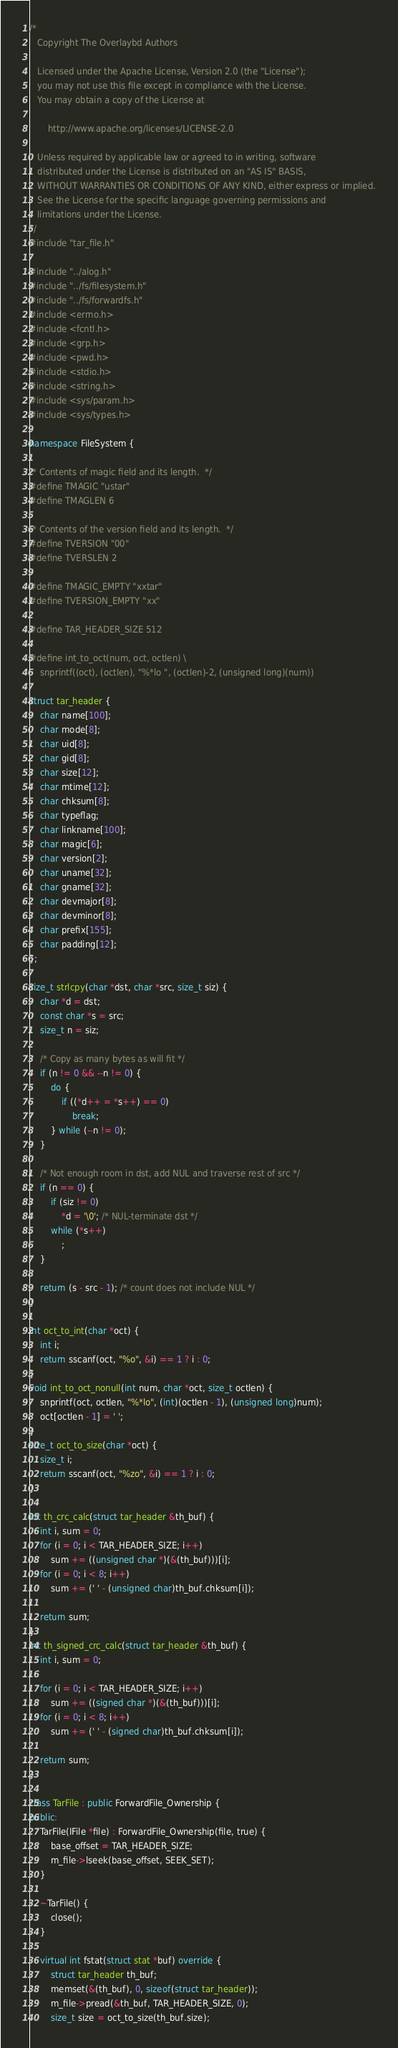<code> <loc_0><loc_0><loc_500><loc_500><_C++_>/*
   Copyright The Overlaybd Authors

   Licensed under the Apache License, Version 2.0 (the "License");
   you may not use this file except in compliance with the License.
   You may obtain a copy of the License at

       http://www.apache.org/licenses/LICENSE-2.0

   Unless required by applicable law or agreed to in writing, software
   distributed under the License is distributed on an "AS IS" BASIS,
   WITHOUT WARRANTIES OR CONDITIONS OF ANY KIND, either express or implied.
   See the License for the specific language governing permissions and
   limitations under the License.
*/
#include "tar_file.h"

#include "../alog.h"
#include "../fs/filesystem.h"
#include "../fs/forwardfs.h"
#include <errno.h>
#include <fcntl.h>
#include <grp.h>
#include <pwd.h>
#include <stdio.h>
#include <string.h>
#include <sys/param.h>
#include <sys/types.h>

namespace FileSystem {

/* Contents of magic field and its length.  */
#define TMAGIC "ustar"
#define TMAGLEN 6

/* Contents of the version field and its length.  */
#define TVERSION "00"
#define TVERSLEN 2

#define TMAGIC_EMPTY "xxtar"
#define TVERSION_EMPTY "xx"

#define TAR_HEADER_SIZE 512

#define int_to_oct(num, oct, octlen) \
    snprintf((oct), (octlen), "%*lo ", (octlen)-2, (unsigned long)(num))

struct tar_header {
    char name[100];
    char mode[8];
    char uid[8];
    char gid[8];
    char size[12];
    char mtime[12];
    char chksum[8];
    char typeflag;
    char linkname[100];
    char magic[6];
    char version[2];
    char uname[32];
    char gname[32];
    char devmajor[8];
    char devminor[8];
    char prefix[155];
    char padding[12];
};

size_t strlcpy(char *dst, char *src, size_t siz) {
    char *d = dst;
    const char *s = src;
    size_t n = siz;

    /* Copy as many bytes as will fit */
    if (n != 0 && --n != 0) {
        do {
            if ((*d++ = *s++) == 0)
                break;
        } while (--n != 0);
    }

    /* Not enough room in dst, add NUL and traverse rest of src */
    if (n == 0) {
        if (siz != 0)
            *d = '\0'; /* NUL-terminate dst */
        while (*s++)
            ;
    }

    return (s - src - 1); /* count does not include NUL */
}

int oct_to_int(char *oct) {
    int i;
    return sscanf(oct, "%o", &i) == 1 ? i : 0;
}
void int_to_oct_nonull(int num, char *oct, size_t octlen) {
    snprintf(oct, octlen, "%*lo", (int)(octlen - 1), (unsigned long)num);
    oct[octlen - 1] = ' ';
}
size_t oct_to_size(char *oct) {
    size_t i;
    return sscanf(oct, "%zo", &i) == 1 ? i : 0;
}

int th_crc_calc(struct tar_header &th_buf) {
    int i, sum = 0;
    for (i = 0; i < TAR_HEADER_SIZE; i++)
        sum += ((unsigned char *)(&(th_buf)))[i];
    for (i = 0; i < 8; i++)
        sum += (' ' - (unsigned char)th_buf.chksum[i]);

    return sum;
}
int th_signed_crc_calc(struct tar_header &th_buf) {
    int i, sum = 0;

    for (i = 0; i < TAR_HEADER_SIZE; i++)
        sum += ((signed char *)(&(th_buf)))[i];
    for (i = 0; i < 8; i++)
        sum += (' ' - (signed char)th_buf.chksum[i]);

    return sum;
}

class TarFile : public ForwardFile_Ownership {
public:
    TarFile(IFile *file) : ForwardFile_Ownership(file, true) {
        base_offset = TAR_HEADER_SIZE;
        m_file->lseek(base_offset, SEEK_SET);
    }

    ~TarFile() {
        close();
    }

    virtual int fstat(struct stat *buf) override {
        struct tar_header th_buf;
        memset(&(th_buf), 0, sizeof(struct tar_header));
        m_file->pread(&th_buf, TAR_HEADER_SIZE, 0);
        size_t size = oct_to_size(th_buf.size);
</code> 